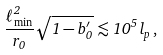Convert formula to latex. <formula><loc_0><loc_0><loc_500><loc_500>\frac { \ell ^ { 2 } _ { \min } } { r _ { 0 } } \sqrt { 1 - b ^ { \prime } _ { 0 } } \lesssim 1 0 ^ { 5 } \, l _ { p } \, ,</formula> 